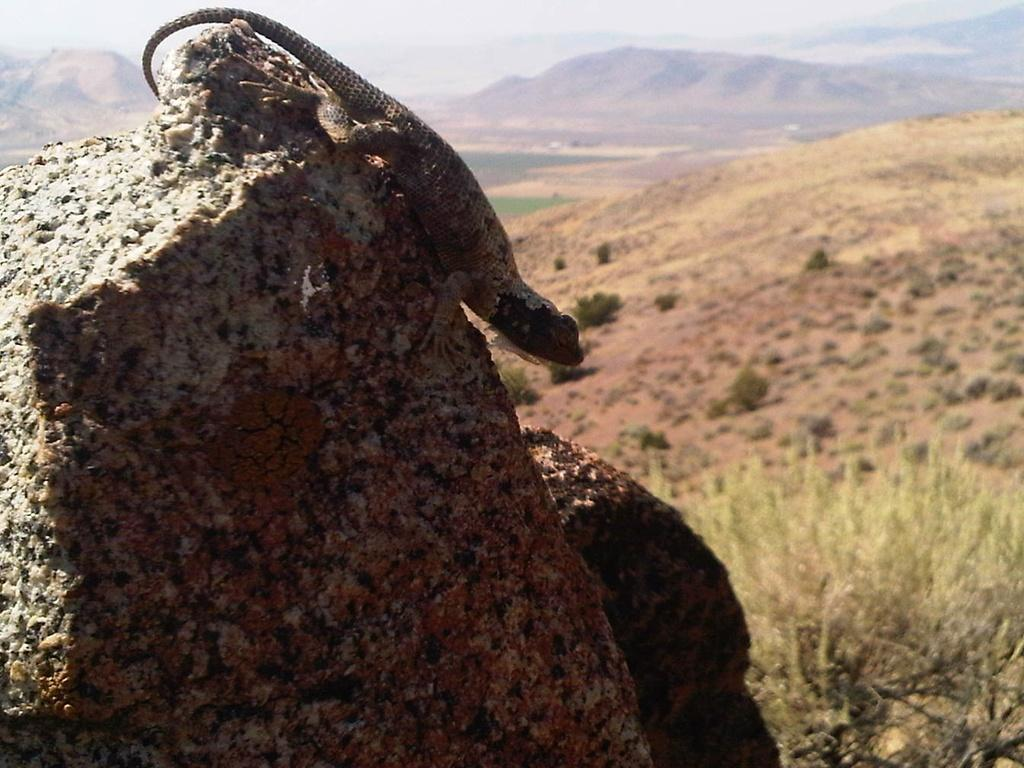What type of animal is on the rock in the image? There is a reptile on a rock in the image. What other natural elements can be seen in the image? There are plants and grass visible in the image. What is visible in the background of the image? There are mountains and the sky visible in the background of the image. How does the reptile sort the grass in the image? The reptile does not sort the grass in the image; it is not performing any sorting activity. 